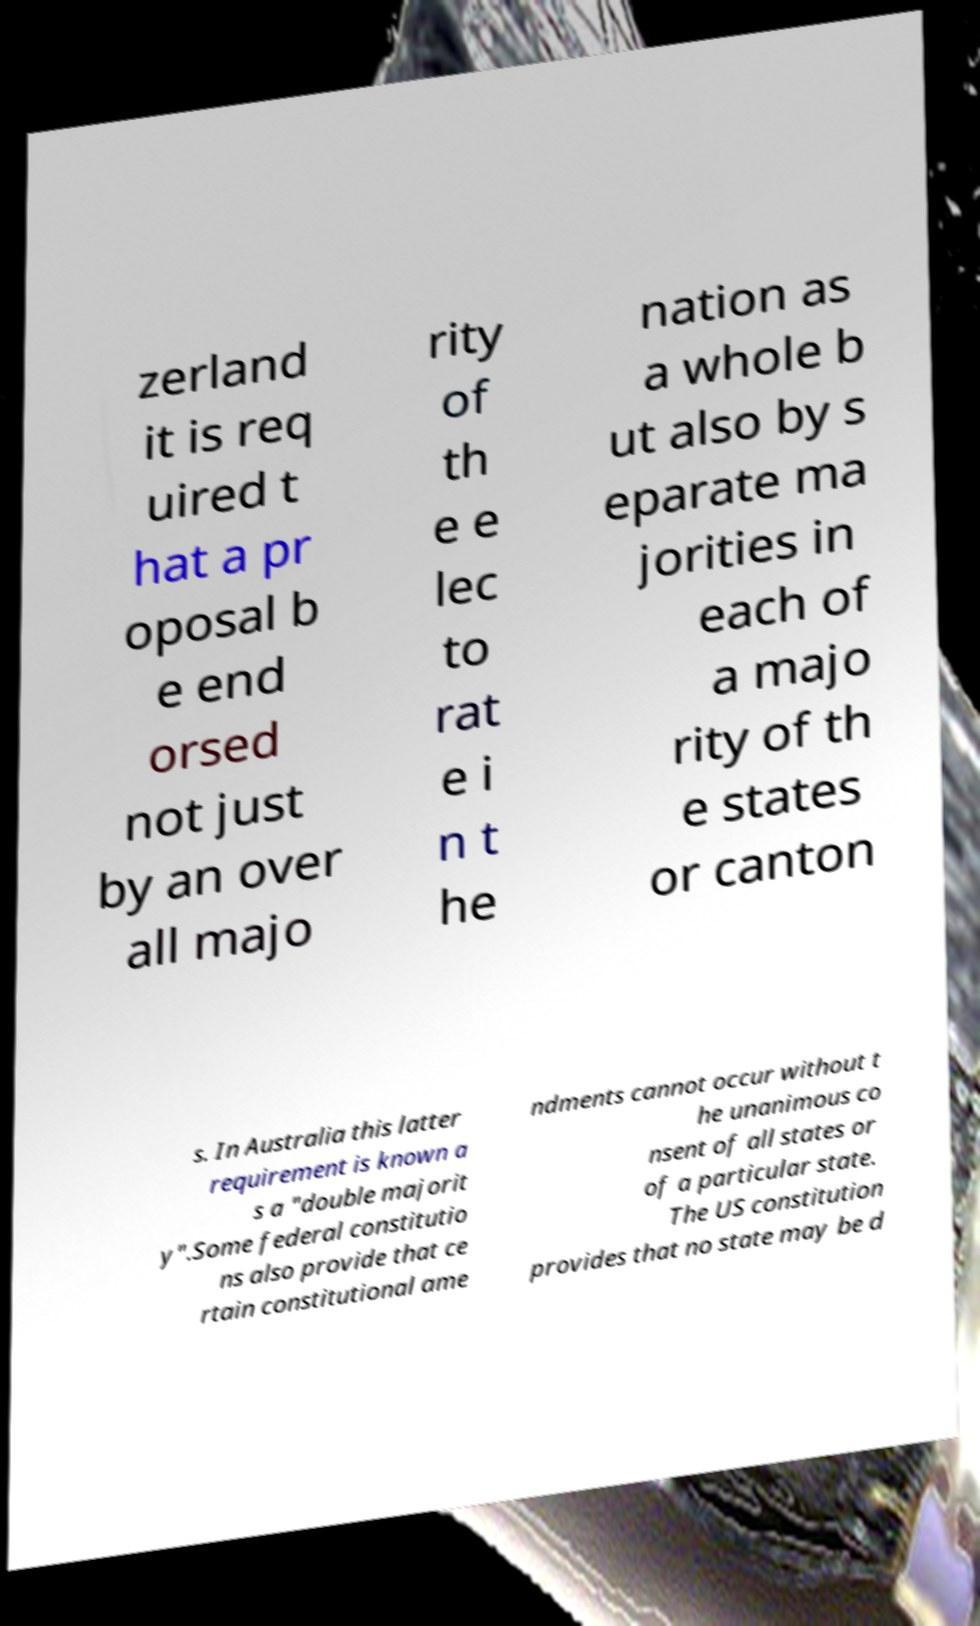Can you read and provide the text displayed in the image?This photo seems to have some interesting text. Can you extract and type it out for me? zerland it is req uired t hat a pr oposal b e end orsed not just by an over all majo rity of th e e lec to rat e i n t he nation as a whole b ut also by s eparate ma jorities in each of a majo rity of th e states or canton s. In Australia this latter requirement is known a s a "double majorit y".Some federal constitutio ns also provide that ce rtain constitutional ame ndments cannot occur without t he unanimous co nsent of all states or of a particular state. The US constitution provides that no state may be d 